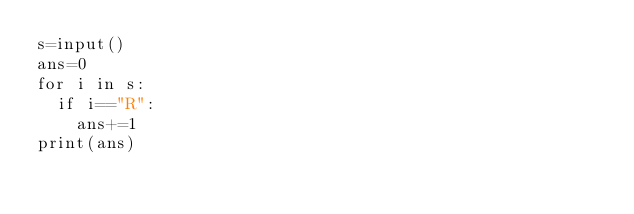Convert code to text. <code><loc_0><loc_0><loc_500><loc_500><_Python_>s=input()
ans=0
for i in s:
  if i=="R":
    ans+=1
print(ans)
</code> 